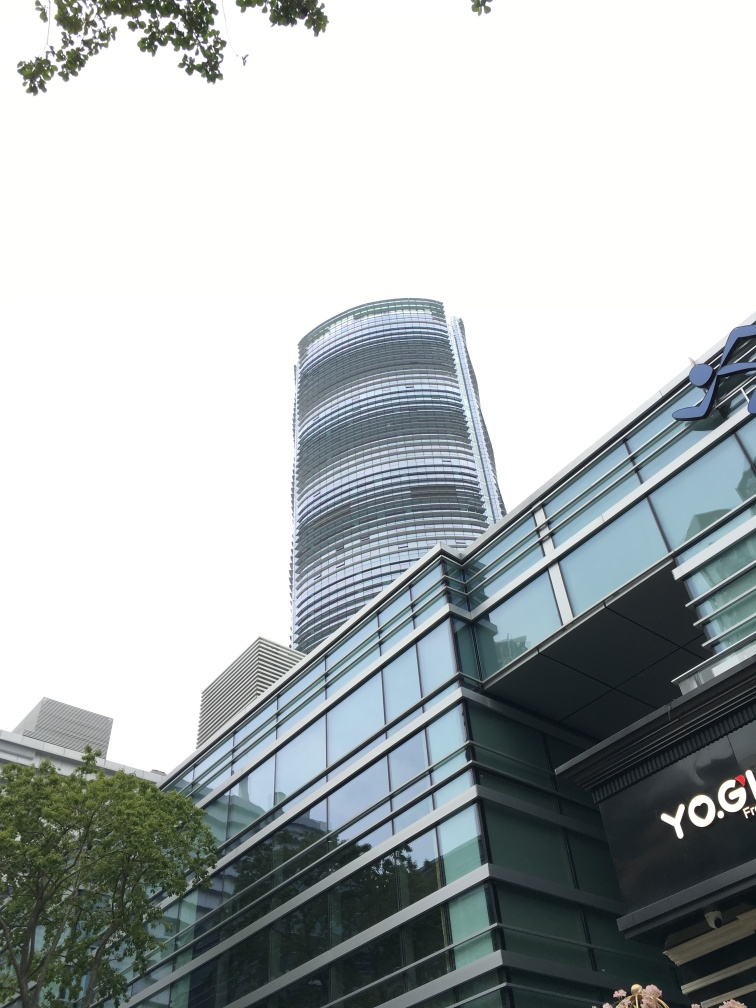How would you describe the architectural style of the building in the background? The building in the background exhibits a modern architectural style, characterized by its sleek glass facade, gentle curves, and the seemingly stratified layers which give it a dynamic and sophisticated appearance. It stands out against the skyline, suggesting a contemporary approach to urban design. 